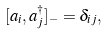<formula> <loc_0><loc_0><loc_500><loc_500>[ a _ { i } , a _ { j } ^ { \dagger } ] _ { - } = \delta _ { i j } ,</formula> 